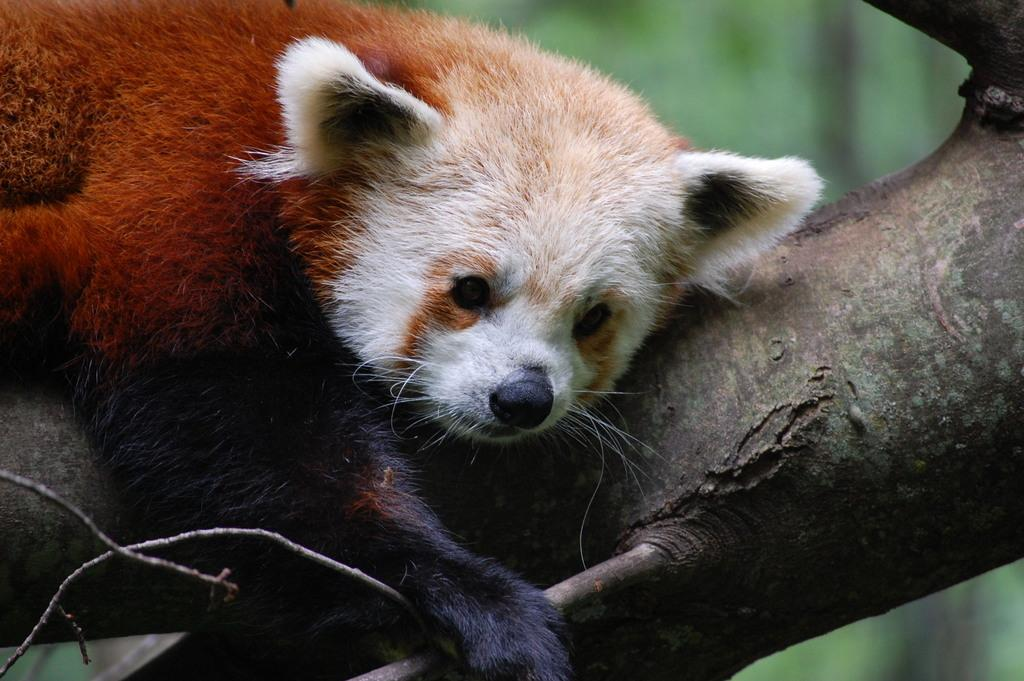What is the main subject in the center of the image? There is a tree in the center of the image. What animal can be seen on the tree? There is a panda on the tree. What colors is the panda wearing? The panda is in red and white color. What level of the chess game is being played in the image? There is no chess game present in the image. What time of day is it in the image, considering the panda's presence? The time of day cannot be determined from the image, as there are no clues about the time. 